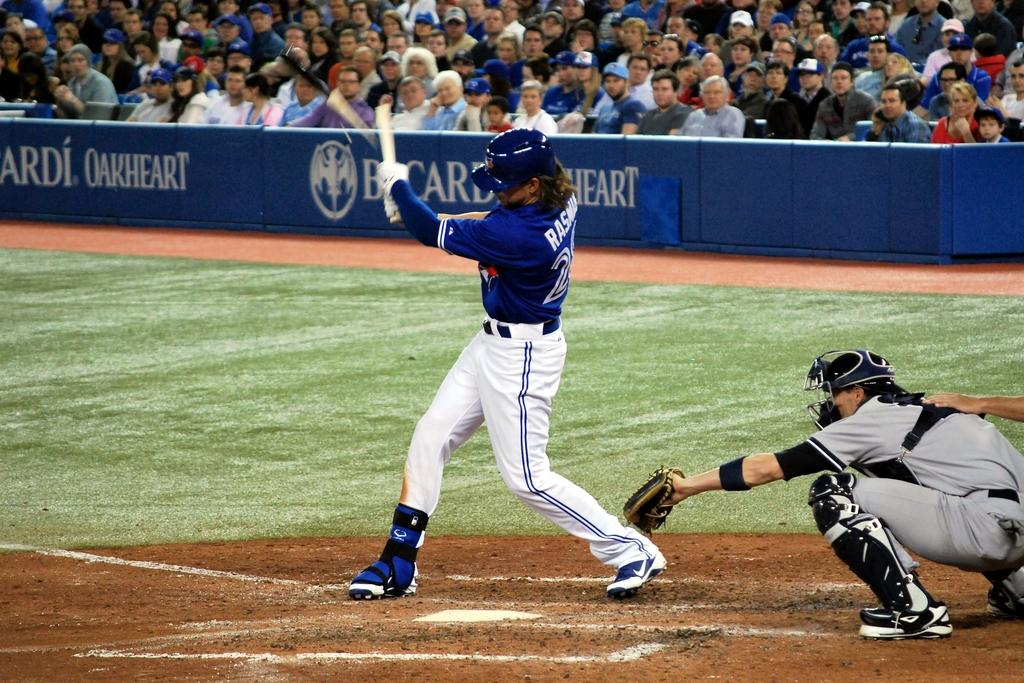<image>
Summarize the visual content of the image. The Sponsor in the baseball stadium is Bircardi Oakheart. 